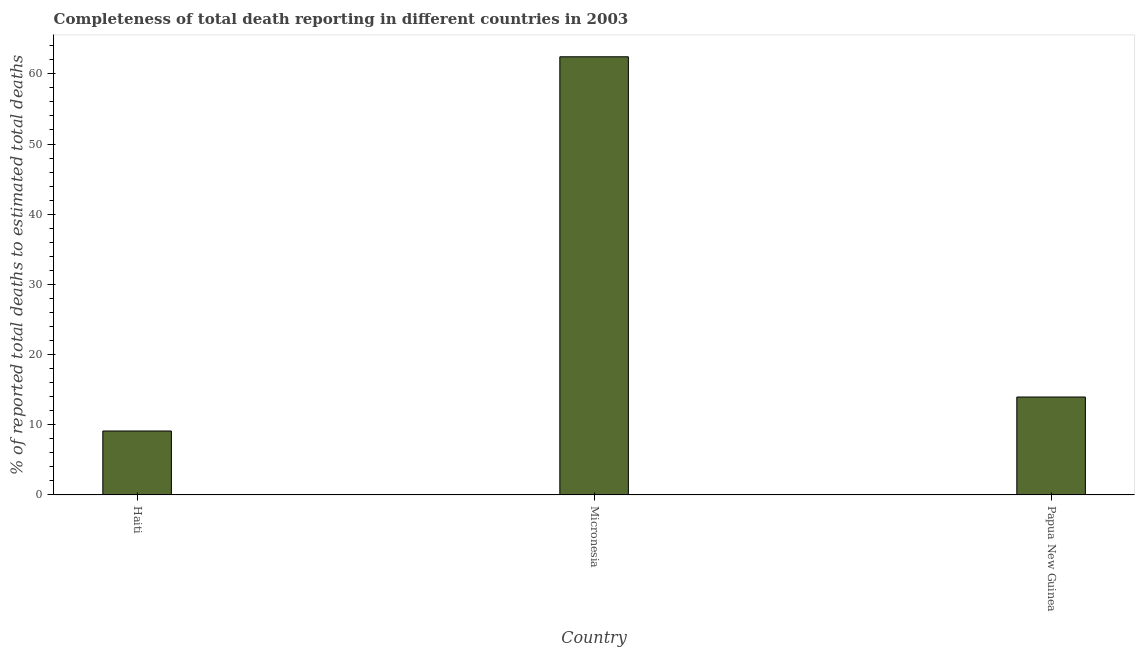Does the graph contain any zero values?
Ensure brevity in your answer.  No. What is the title of the graph?
Give a very brief answer. Completeness of total death reporting in different countries in 2003. What is the label or title of the Y-axis?
Provide a short and direct response. % of reported total deaths to estimated total deaths. What is the completeness of total death reports in Micronesia?
Give a very brief answer. 62.43. Across all countries, what is the maximum completeness of total death reports?
Offer a very short reply. 62.43. Across all countries, what is the minimum completeness of total death reports?
Your response must be concise. 9.11. In which country was the completeness of total death reports maximum?
Your answer should be compact. Micronesia. In which country was the completeness of total death reports minimum?
Provide a short and direct response. Haiti. What is the sum of the completeness of total death reports?
Offer a terse response. 85.48. What is the difference between the completeness of total death reports in Micronesia and Papua New Guinea?
Offer a very short reply. 48.48. What is the average completeness of total death reports per country?
Provide a short and direct response. 28.5. What is the median completeness of total death reports?
Offer a very short reply. 13.95. What is the ratio of the completeness of total death reports in Haiti to that in Papua New Guinea?
Ensure brevity in your answer.  0.65. What is the difference between the highest and the second highest completeness of total death reports?
Your response must be concise. 48.48. What is the difference between the highest and the lowest completeness of total death reports?
Keep it short and to the point. 53.32. In how many countries, is the completeness of total death reports greater than the average completeness of total death reports taken over all countries?
Offer a very short reply. 1. What is the difference between two consecutive major ticks on the Y-axis?
Your answer should be compact. 10. What is the % of reported total deaths to estimated total deaths in Haiti?
Offer a very short reply. 9.11. What is the % of reported total deaths to estimated total deaths in Micronesia?
Ensure brevity in your answer.  62.43. What is the % of reported total deaths to estimated total deaths of Papua New Guinea?
Offer a very short reply. 13.95. What is the difference between the % of reported total deaths to estimated total deaths in Haiti and Micronesia?
Keep it short and to the point. -53.32. What is the difference between the % of reported total deaths to estimated total deaths in Haiti and Papua New Guinea?
Your response must be concise. -4.84. What is the difference between the % of reported total deaths to estimated total deaths in Micronesia and Papua New Guinea?
Offer a terse response. 48.48. What is the ratio of the % of reported total deaths to estimated total deaths in Haiti to that in Micronesia?
Provide a short and direct response. 0.15. What is the ratio of the % of reported total deaths to estimated total deaths in Haiti to that in Papua New Guinea?
Ensure brevity in your answer.  0.65. What is the ratio of the % of reported total deaths to estimated total deaths in Micronesia to that in Papua New Guinea?
Offer a very short reply. 4.47. 